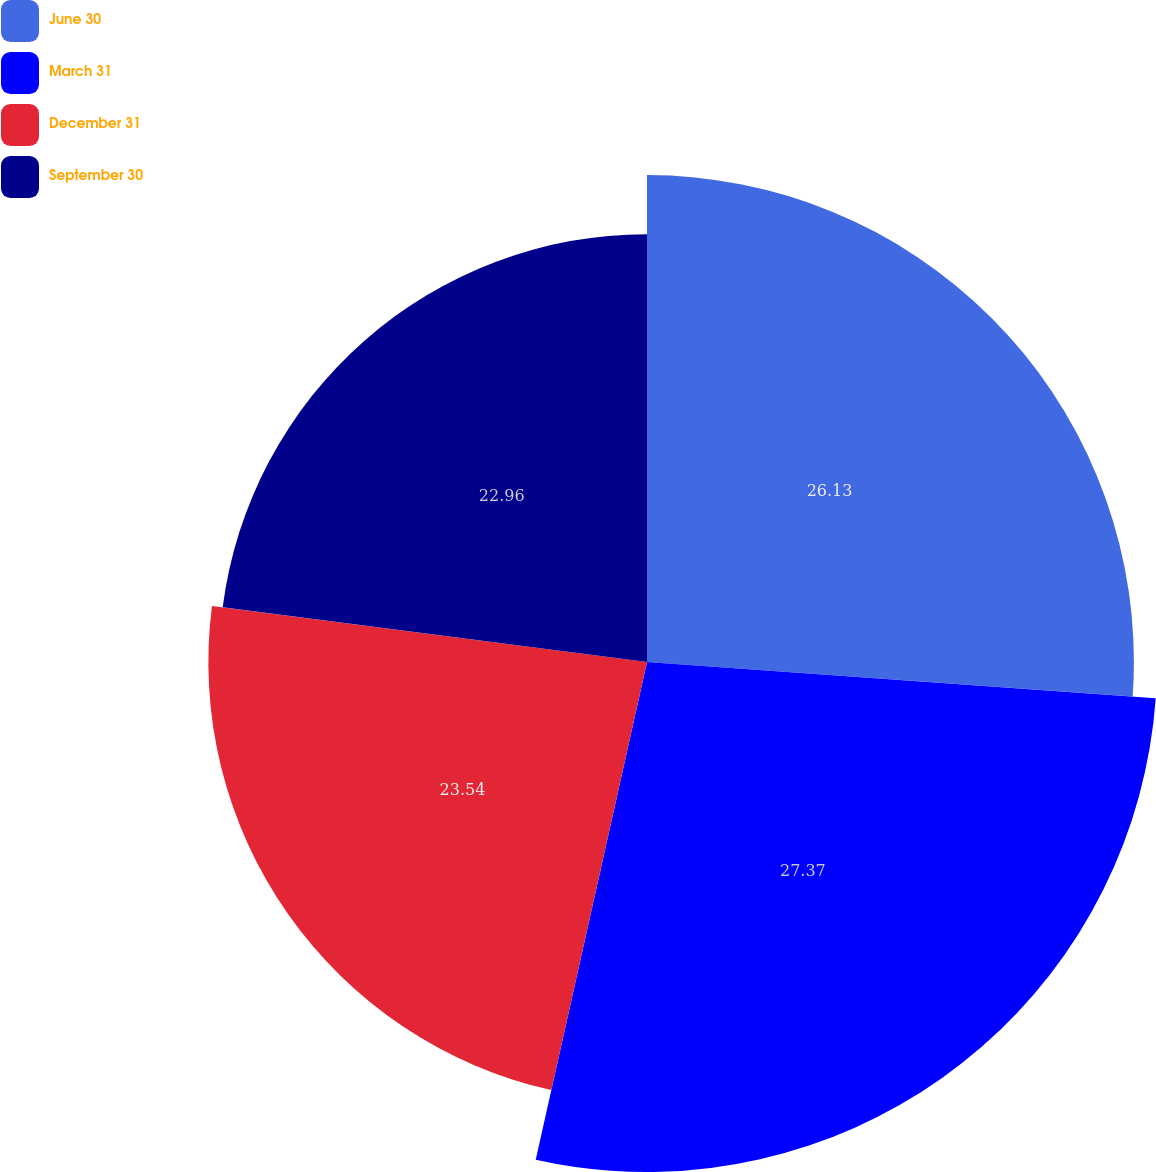Convert chart. <chart><loc_0><loc_0><loc_500><loc_500><pie_chart><fcel>June 30<fcel>March 31<fcel>December 31<fcel>September 30<nl><fcel>26.13%<fcel>27.37%<fcel>23.54%<fcel>22.96%<nl></chart> 